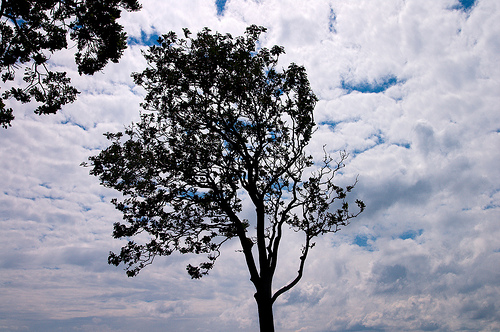<image>
Is the sky behind the tree? Yes. From this viewpoint, the sky is positioned behind the tree, with the tree partially or fully occluding the sky. 